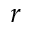Convert formula to latex. <formula><loc_0><loc_0><loc_500><loc_500>r</formula> 